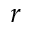Convert formula to latex. <formula><loc_0><loc_0><loc_500><loc_500>r</formula> 